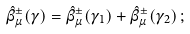<formula> <loc_0><loc_0><loc_500><loc_500>\hat { \beta } ^ { \pm } _ { \mu } ( \gamma ) = \hat { \beta } ^ { \pm } _ { \mu } ( \gamma _ { 1 } ) + \hat { \beta } ^ { \pm } _ { \mu } ( \gamma _ { 2 } ) \, ;</formula> 